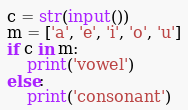Convert code to text. <code><loc_0><loc_0><loc_500><loc_500><_Python_>c = str(input())
m = ['a', 'e', 'i', 'o', 'u']
if c in m:
    print('vowel')
else:
    print('consonant')</code> 